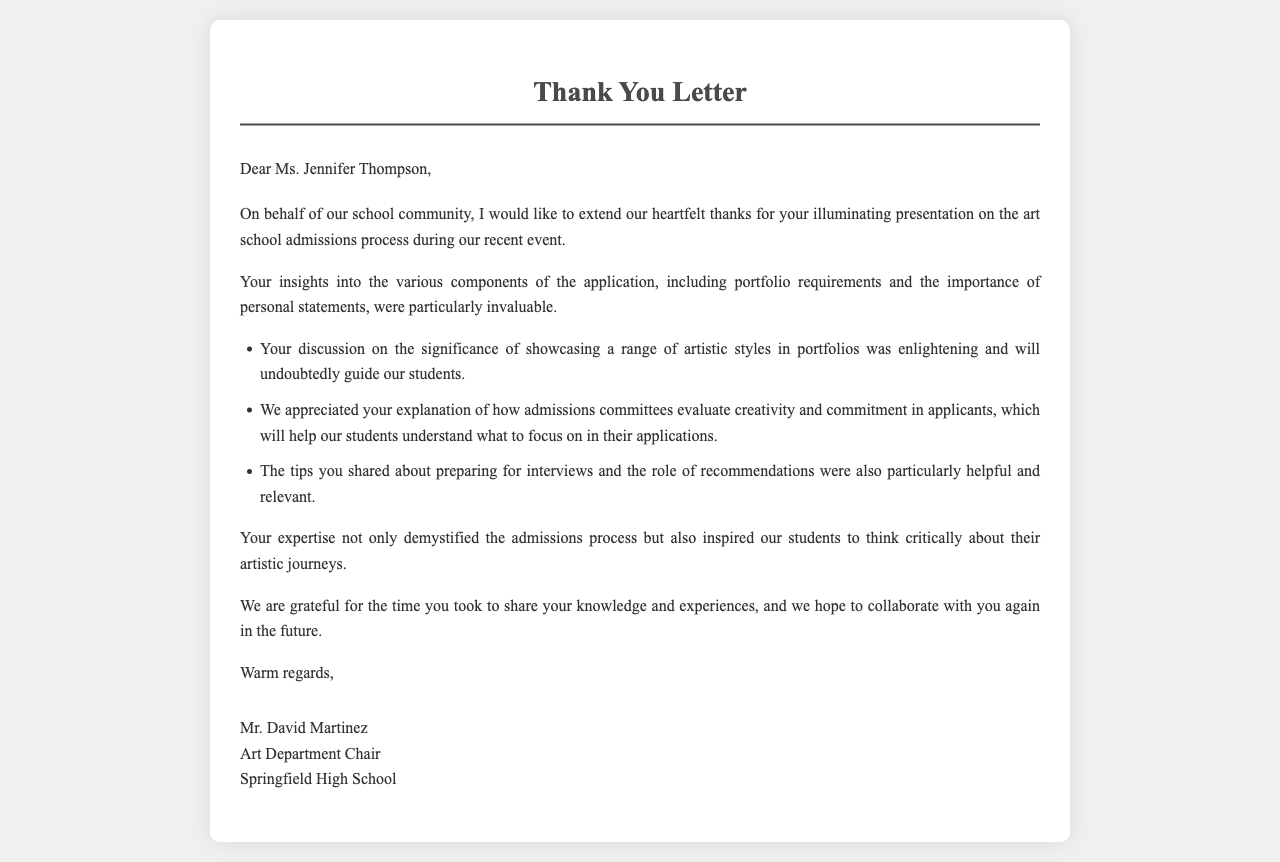What is the name of the guest speaker? The speaker's name is mentioned in the greeting of the letter.
Answer: Ms. Jennifer Thompson What is the title of the letter? The title is stated at the top of the document.
Answer: Thank You Letter Who is the author of the letter? The author is mentioned at the end of the letter.
Answer: Mr. David Martinez What is the primary topic of Ms. Thompson's presentation? The topic is specified in the first paragraph of the letter.
Answer: art school admissions process How many specific insights were mentioned from the presentation? The number of listed insights can be counted in the bullet points.
Answer: Three What does the author express gratitude for? The gratitude is specifically directed towards the insights shared during the presentation.
Answer: time and knowledge What does the letter hope for in the future? The future aspect mentioned in the conclusion highlights a desire for continued collaboration.
Answer: collaborate again What is one component of the application that was discussed? One component mentioned in the context of the application process.
Answer: portfolio requirements What does the author say about personal statements? Personal statements are highlighted as an important part of the application.
Answer: importance of personal statements 